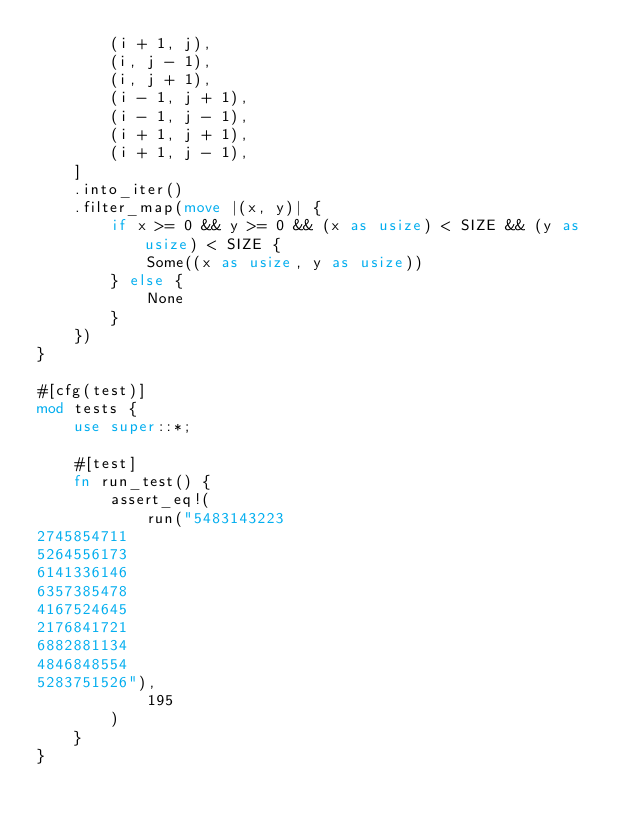<code> <loc_0><loc_0><loc_500><loc_500><_Rust_>        (i + 1, j),
        (i, j - 1),
        (i, j + 1),
        (i - 1, j + 1),
        (i - 1, j - 1),
        (i + 1, j + 1),
        (i + 1, j - 1),
    ]
    .into_iter()
    .filter_map(move |(x, y)| {
        if x >= 0 && y >= 0 && (x as usize) < SIZE && (y as usize) < SIZE {
            Some((x as usize, y as usize))
        } else {
            None
        }
    })
}

#[cfg(test)]
mod tests {
    use super::*;

    #[test]
    fn run_test() {
        assert_eq!(
            run("5483143223
2745854711
5264556173
6141336146
6357385478
4167524645
2176841721
6882881134
4846848554
5283751526"),
            195
        )
    }
}
</code> 